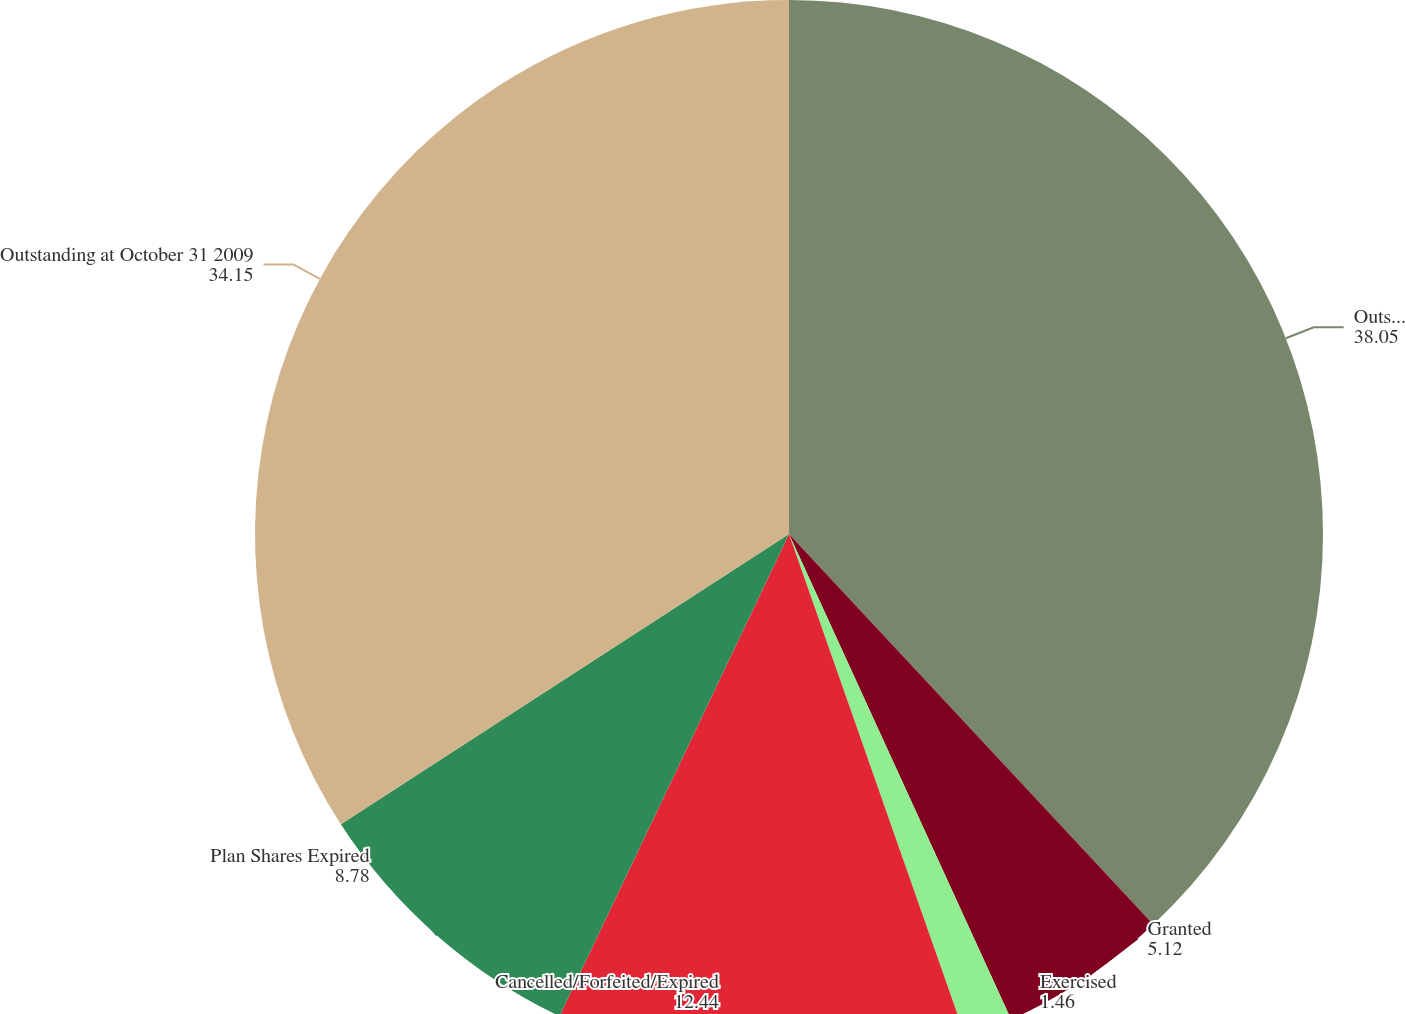Convert chart to OTSL. <chart><loc_0><loc_0><loc_500><loc_500><pie_chart><fcel>Outstanding at October 31 2008<fcel>Granted<fcel>Exercised<fcel>Cancelled/Forfeited/Expired<fcel>Plan Shares Expired<fcel>Outstanding at October 31 2009<nl><fcel>38.05%<fcel>5.12%<fcel>1.46%<fcel>12.44%<fcel>8.78%<fcel>34.15%<nl></chart> 